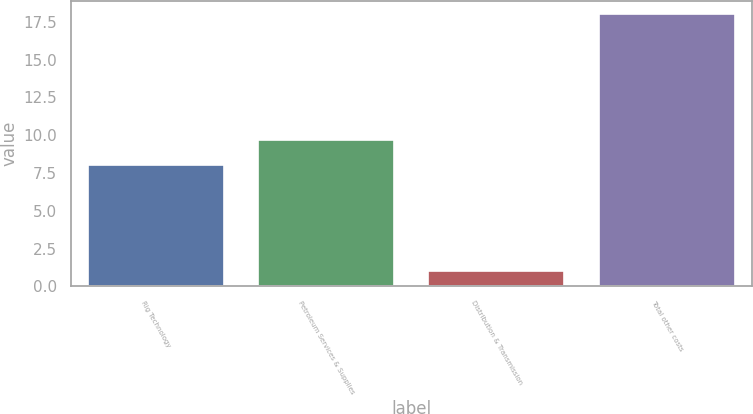<chart> <loc_0><loc_0><loc_500><loc_500><bar_chart><fcel>Rig Technology<fcel>Petroleum Services & Supplies<fcel>Distribution & Transmission<fcel>Total other costs<nl><fcel>8<fcel>9.7<fcel>1<fcel>18<nl></chart> 